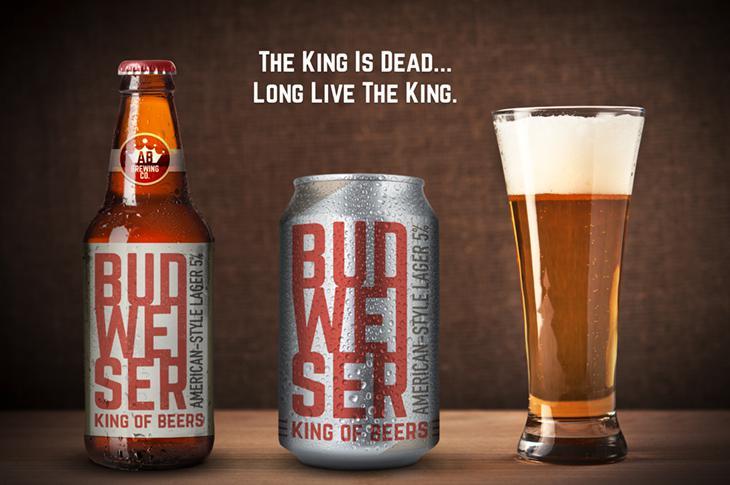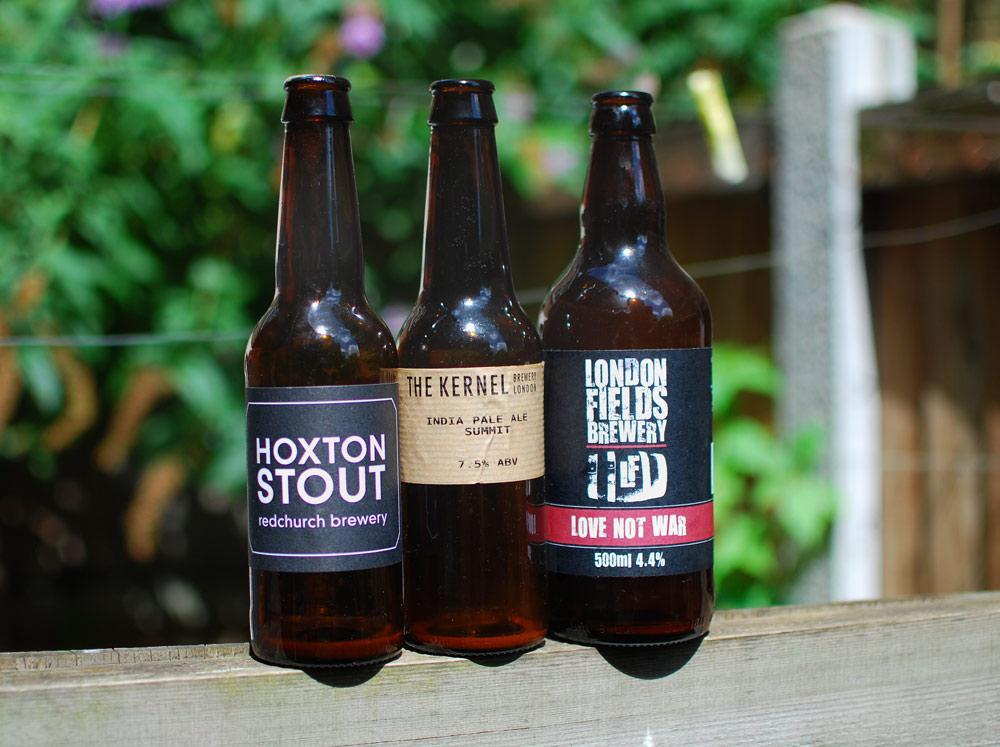The first image is the image on the left, the second image is the image on the right. For the images displayed, is the sentence "A tall glass of beer is shown in only one image." factually correct? Answer yes or no. Yes. 